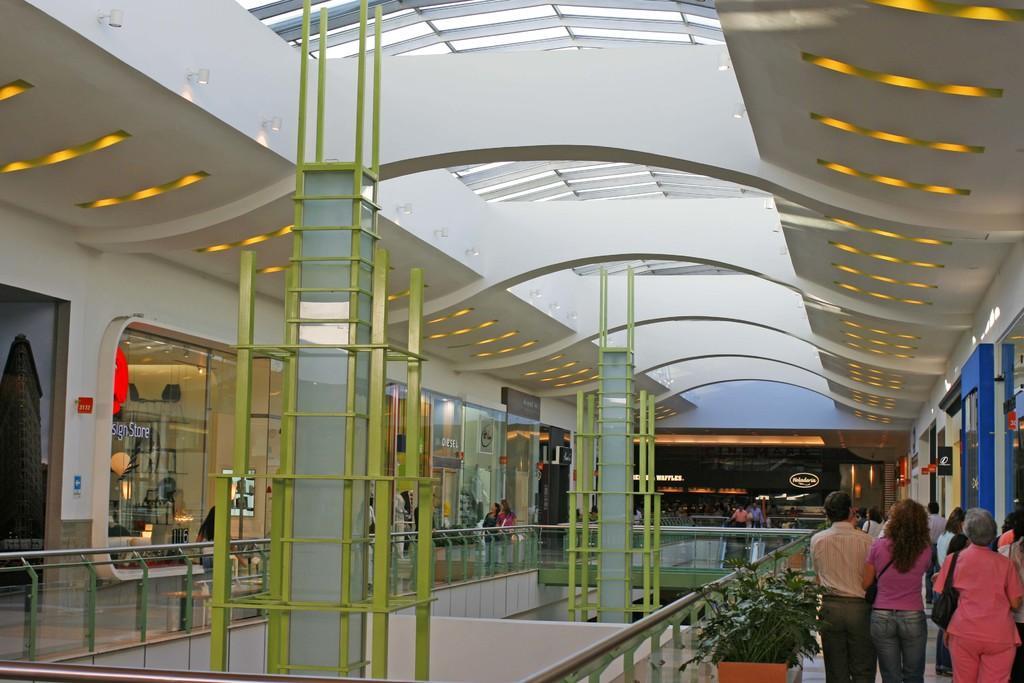Please provide a concise description of this image. This image consists of a building. In which there are many persons walking. And we can see the potted plants. In the middle, three are pillars. At the top, there is a roof along with lights. It looks like a mall. On the left and right, there are shops. 